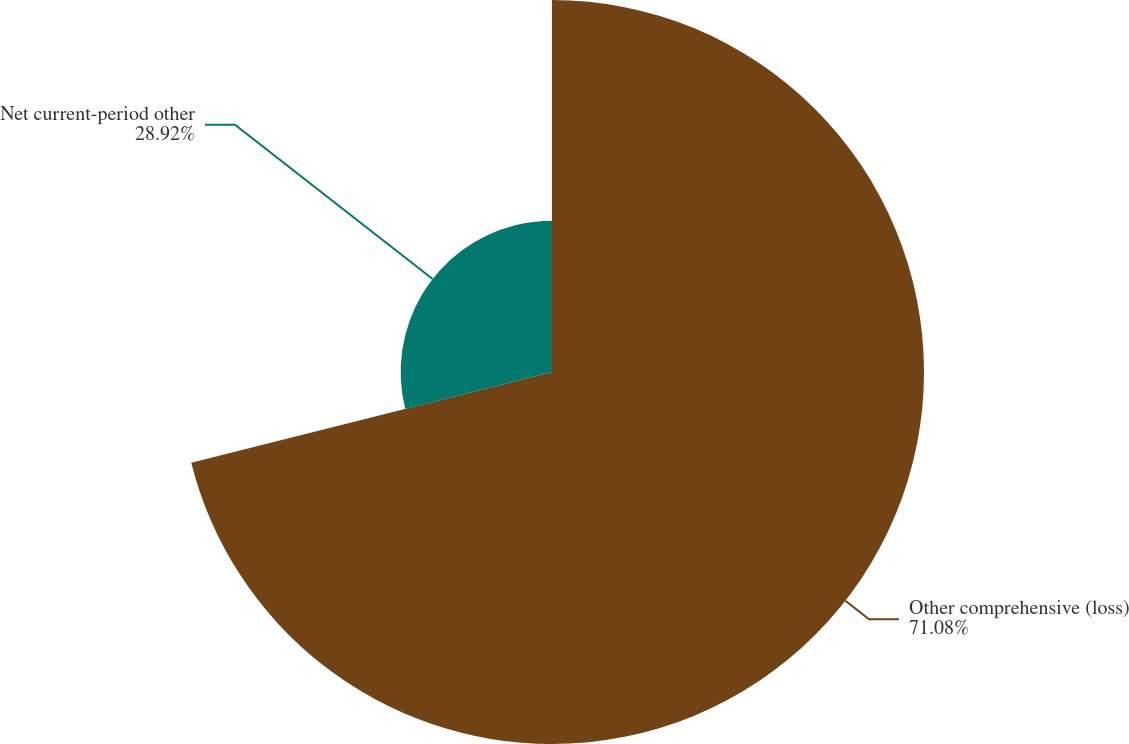Convert chart to OTSL. <chart><loc_0><loc_0><loc_500><loc_500><pie_chart><fcel>Other comprehensive (loss)<fcel>Net current-period other<nl><fcel>71.08%<fcel>28.92%<nl></chart> 